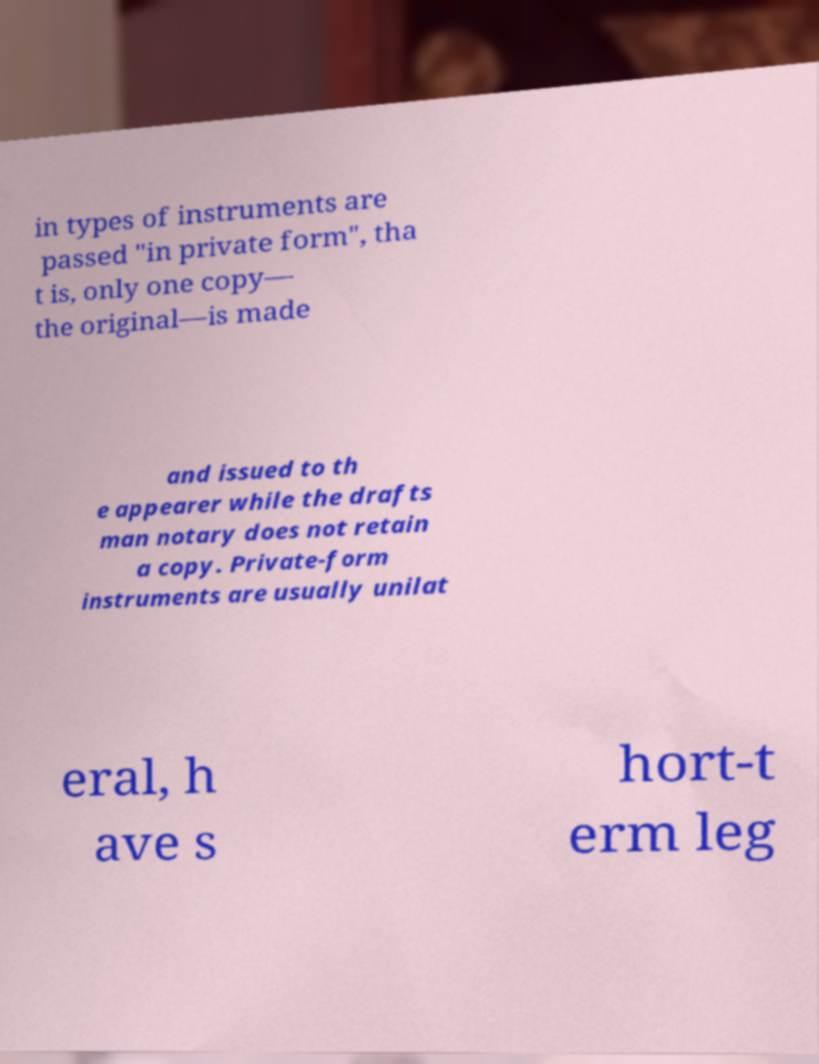Could you assist in decoding the text presented in this image and type it out clearly? in types of instruments are passed "in private form", tha t is, only one copy— the original—is made and issued to th e appearer while the drafts man notary does not retain a copy. Private-form instruments are usually unilat eral, h ave s hort-t erm leg 